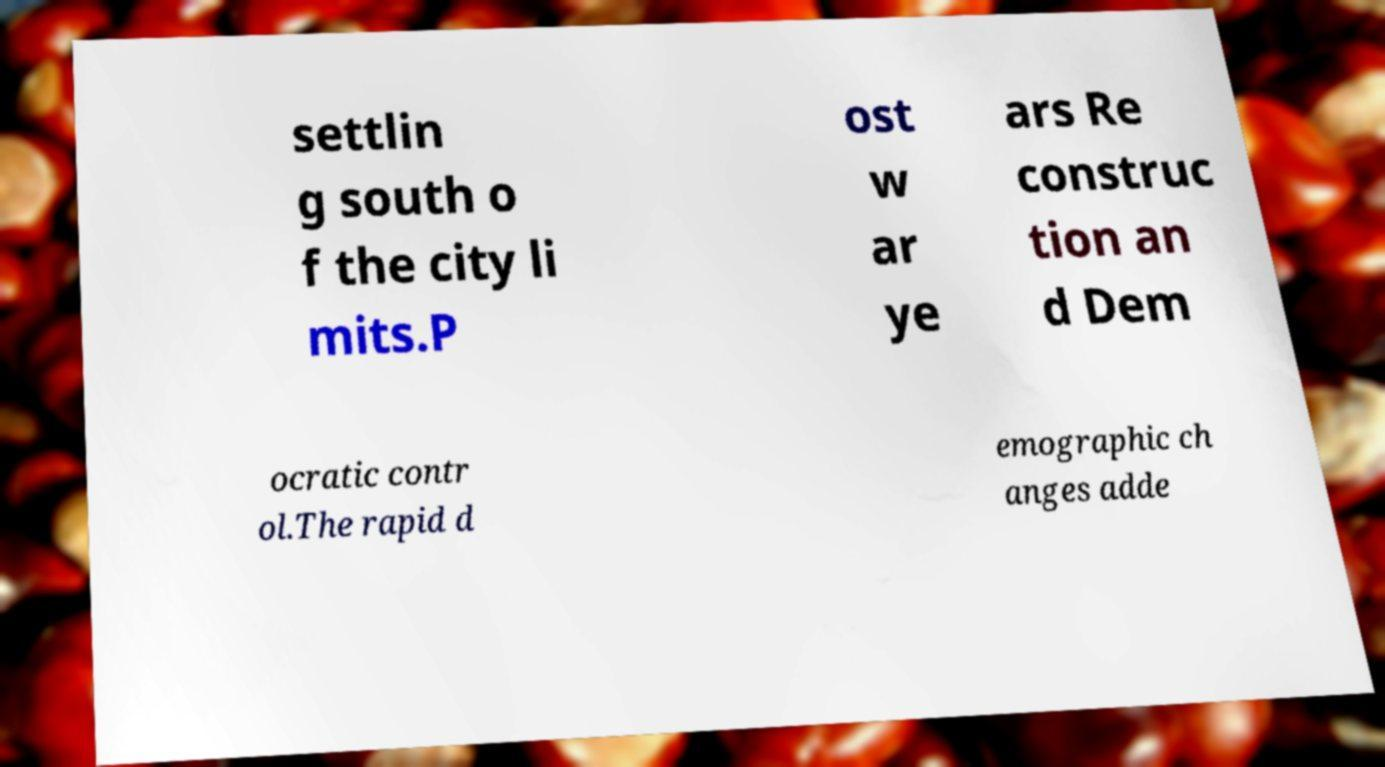I need the written content from this picture converted into text. Can you do that? settlin g south o f the city li mits.P ost w ar ye ars Re construc tion an d Dem ocratic contr ol.The rapid d emographic ch anges adde 